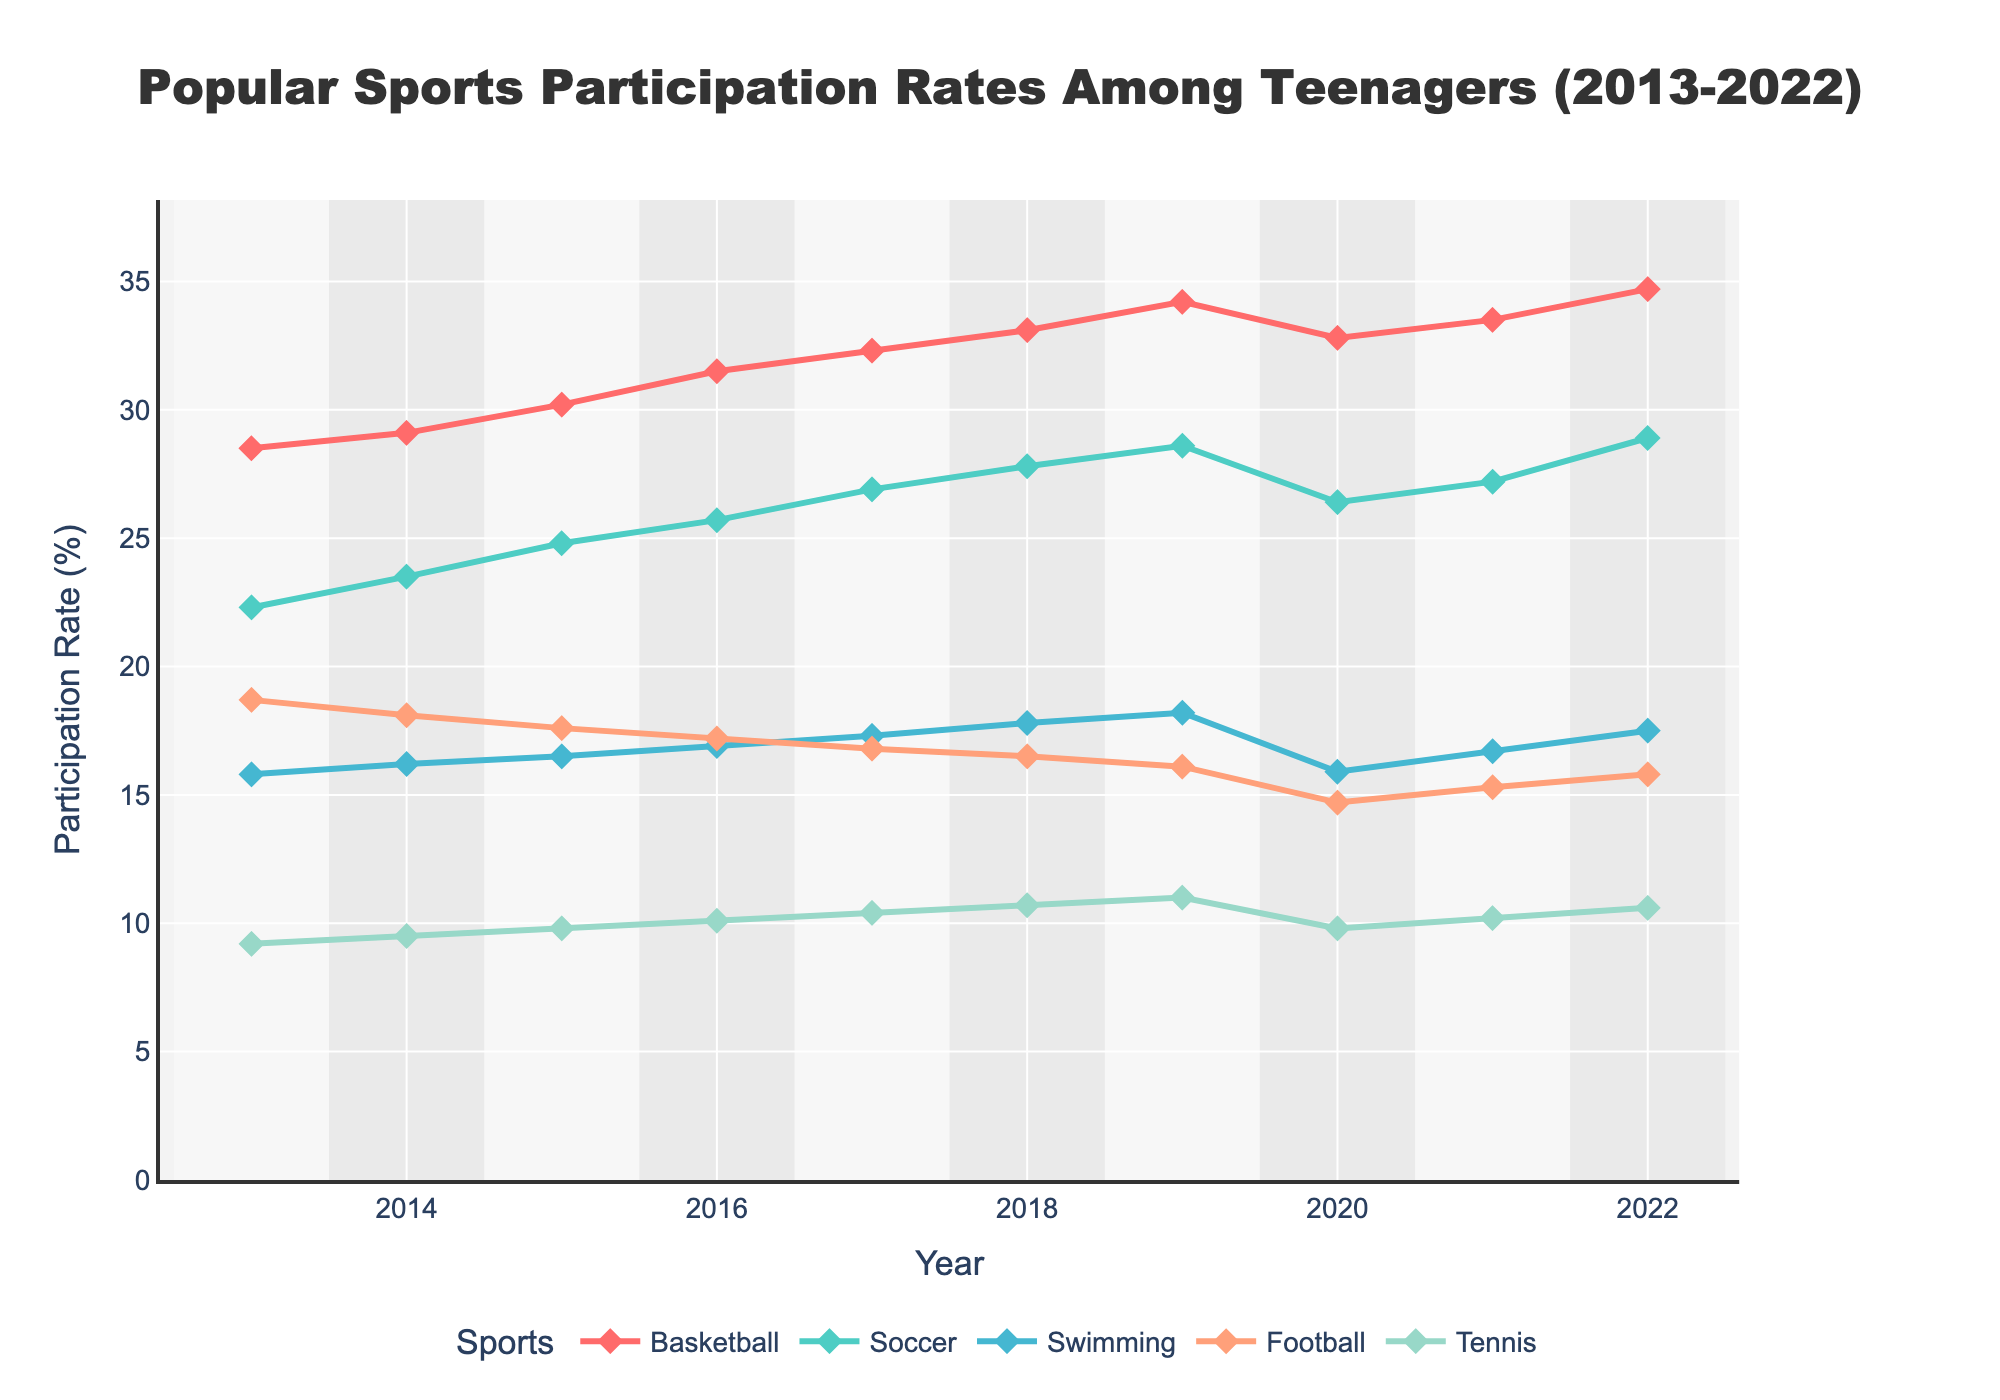Which sport had the highest participation rate in 2019? By inspecting the line chart, we see that the sport line for Basketball is at the peak position in 2019. All other sport lines are below it.
Answer: Basketball Between 2013 and 2022, which sport showed the most significant increase in participation rate? Basketball increased from 28.5% in 2013 to 34.7% in 2022, a change of 6.2 percentage points, greater than any other sport.
Answer: Basketball Which year did Soccer participation peak at the highest value? By observing the lines for Soccer, the highest point is seen in the year 2022.
Answer: 2022 How did the participation rate for Football change from 2018 to 2020? By inspecting the Football line, the participation rate declined from 16.5% in 2018 to 14.7% in 2020.
Answer: Declined Which two sports had the closest participation rates in 2020? Observing the lines from the figure for 2020, we notice that Swimming and Tennis converge closely at around 15.9% and 14.7% respectively.
Answer: Swimming and Football Was Tennis participation ever higher than Soccer participation in any year from 2013 to 2022? By comparing the lines for Soccer and Tennis, we see that Soccer always maintains a higher participation rate than Tennis throughout all the years.
Answer: No In which years did Basketball participation rate increase? By following the Basketball line from 2013 to 2022, the participation rate increases in all years except for a slight dip in 2020.
Answer: 2013-2019, 2021-2022 From 2017 to 2018, which sport had the largest increase in participation rate? By comparing the increases in each sport, Basketball rose from 32.3% to 33.1%, which is the largest increase among the sports listed.
Answer: Basketball Which sport maintained a consistent participation rate around 10% by the end of the decade? Observing Tennis, its participation rate was consistently around 9.2% at the start and grew gradually to 10.6% by 2022.
Answer: Tennis On average, how much did Swimming participation change per year between 2013 and 2019? Calculate the total change in Swimming from 15.8% to 18.2%, which is 2.4 percentage points over 6 years (18.2 - 15.8 = 2.4). Divide 2.4/6 yields an average yearly change of 0.4.
Answer: 0.4 